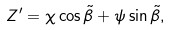Convert formula to latex. <formula><loc_0><loc_0><loc_500><loc_500>Z ^ { \prime } = \chi \cos \tilde { \beta } + \psi \sin \tilde { \beta } ,</formula> 